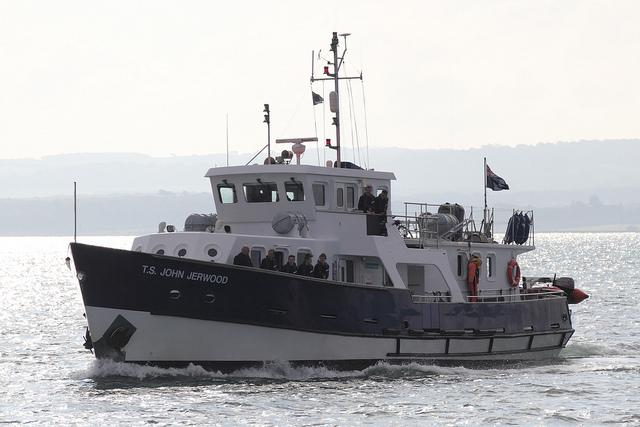Why is there writing on the boat? boat name 